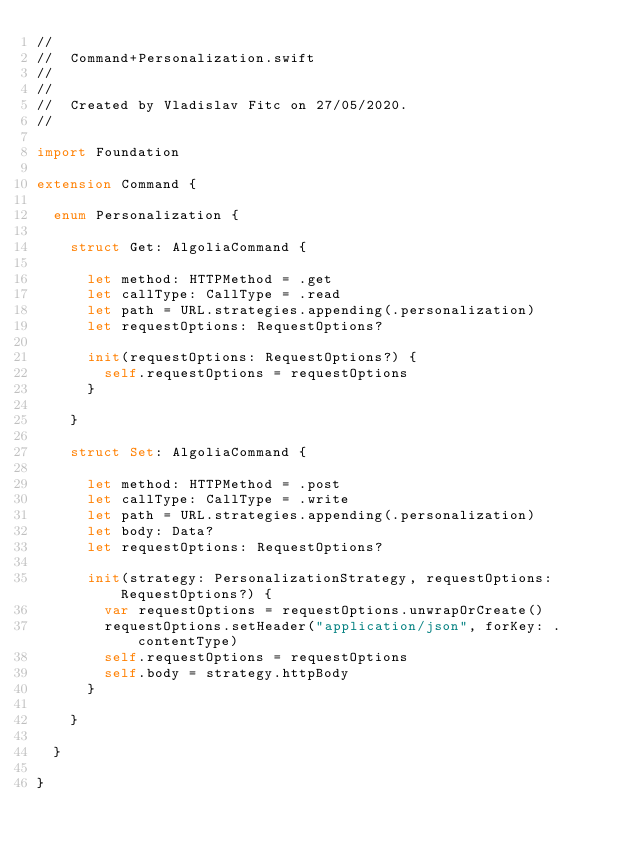<code> <loc_0><loc_0><loc_500><loc_500><_Swift_>//
//  Command+Personalization.swift
//  
//
//  Created by Vladislav Fitc on 27/05/2020.
//

import Foundation

extension Command {

  enum Personalization {

    struct Get: AlgoliaCommand {

      let method: HTTPMethod = .get
      let callType: CallType = .read
      let path = URL.strategies.appending(.personalization)
      let requestOptions: RequestOptions?

      init(requestOptions: RequestOptions?) {
        self.requestOptions = requestOptions
      }

    }

    struct Set: AlgoliaCommand {

      let method: HTTPMethod = .post
      let callType: CallType = .write
      let path = URL.strategies.appending(.personalization)
      let body: Data?
      let requestOptions: RequestOptions?

      init(strategy: PersonalizationStrategy, requestOptions: RequestOptions?) {
        var requestOptions = requestOptions.unwrapOrCreate()
        requestOptions.setHeader("application/json", forKey: .contentType)
        self.requestOptions = requestOptions
        self.body = strategy.httpBody
      }

    }

  }

}
</code> 